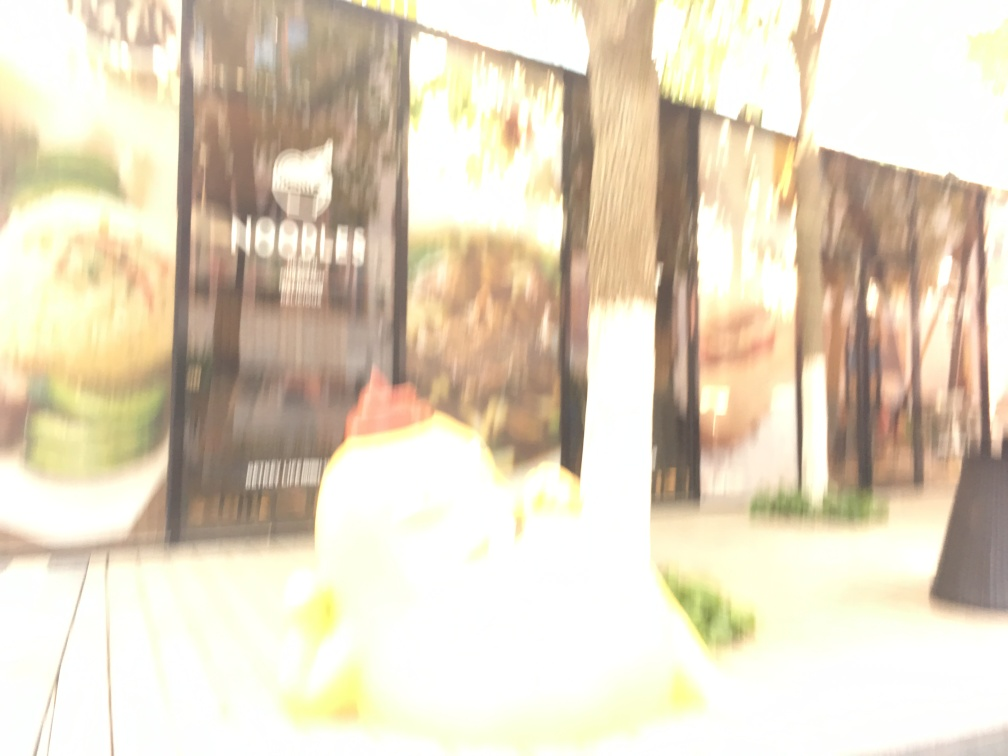What is the problem with the image quality? The image suffers from overexposure, which leads to the loss of detail in the highlights, and it is blurry, lacking sharpness and clarity. These characteristics typically result from excessive light during the exposure or a longer exposure time without stable camera support, and possibly a focus issue, which in culmination affect the quality of the photograph. 